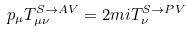<formula> <loc_0><loc_0><loc_500><loc_500>p _ { \mu } T _ { \mu \nu } ^ { S \rightarrow A V } = 2 m i T _ { \nu } ^ { S \rightarrow P V }</formula> 